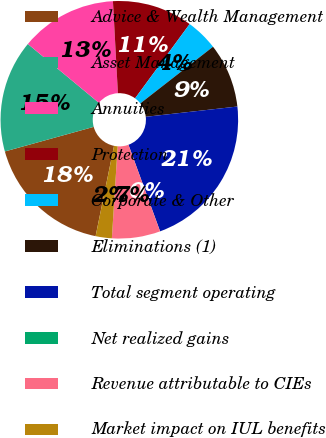Convert chart to OTSL. <chart><loc_0><loc_0><loc_500><loc_500><pie_chart><fcel>Advice & Wealth Management<fcel>Asset Management<fcel>Annuities<fcel>Protection<fcel>Corporate & Other<fcel>Eliminations (1)<fcel>Total segment operating<fcel>Net realized gains<fcel>Revenue attributable to CIEs<fcel>Market impact on IUL benefits<nl><fcel>17.5%<fcel>15.31%<fcel>13.13%<fcel>10.94%<fcel>4.38%<fcel>8.76%<fcel>21.2%<fcel>0.01%<fcel>6.57%<fcel>2.2%<nl></chart> 